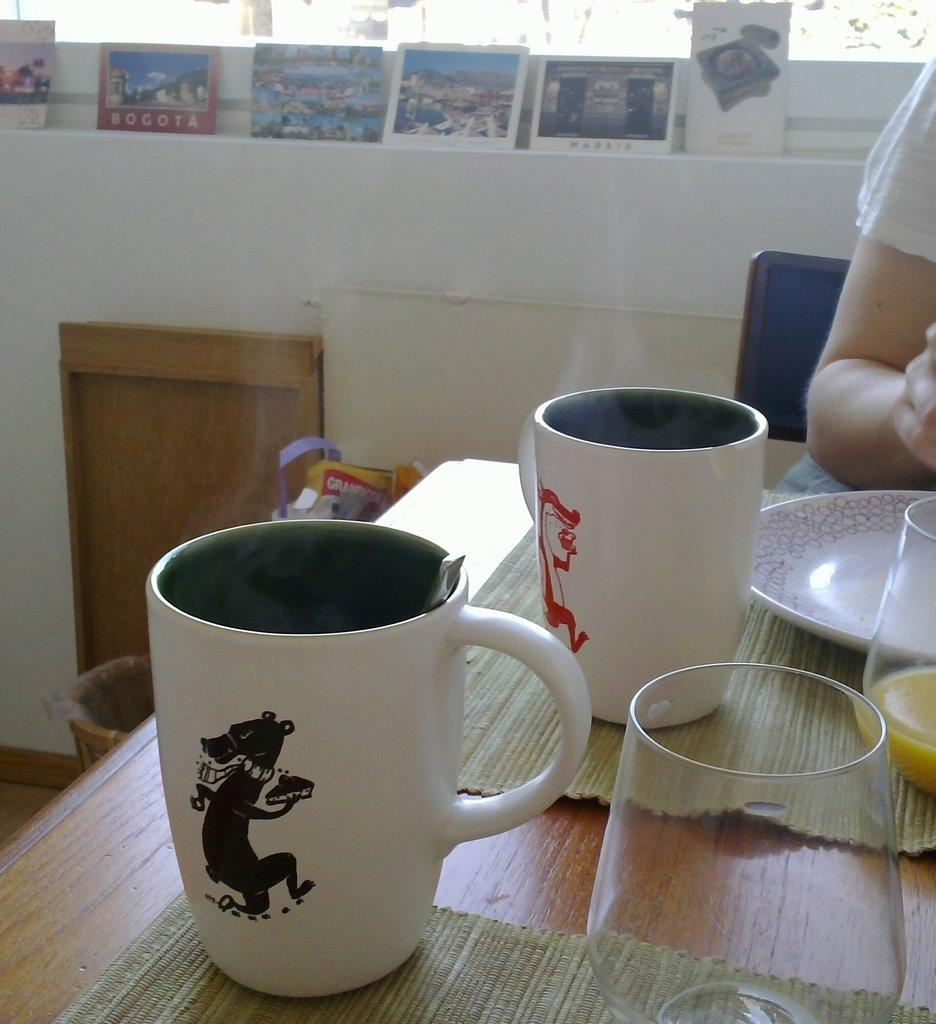What objects are on the table in the image? There are cups and glasses on the table in the image. Where is the person located in the image? The person is in the right corner of the image. What can be seen on the wall in the background? There are pictures on the wall in the background. Can you hear the sound of the ear in the image? There is no ear present in the image, so it is not possible to hear any sound related to it. 